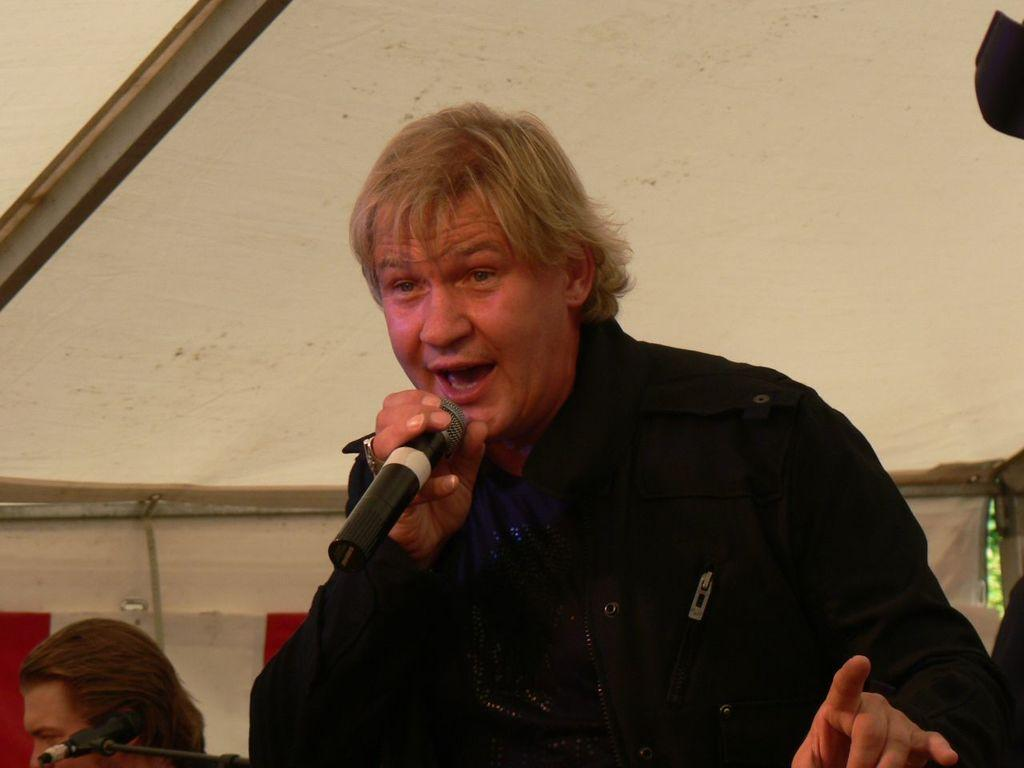What is the person in the image wearing? The person is wearing a black dress in the image. What is the person holding in the image? The person is holding a mic in the image. What else can be seen in the image besides the person? There is a mic, a stand, and another person's face visible in the image. How would you describe the background of the image? The background of the image is in cream and brown colors. What type of quilt is being used as a backdrop in the image? There is no quilt present in the image; it features a person wearing a black dress, holding a mic, and standing in front of a stand. Can you see a van in the background of the image? There is no van visible in the image; the background consists of cream and brown colors. 